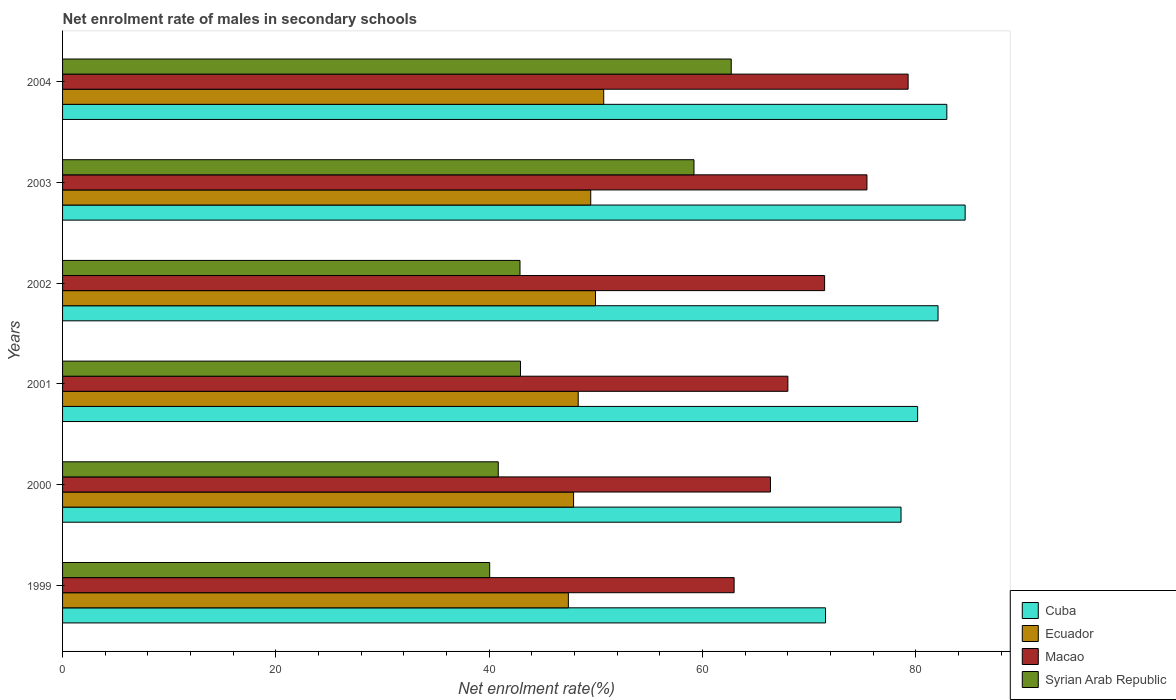How many bars are there on the 4th tick from the bottom?
Make the answer very short. 4. In how many cases, is the number of bars for a given year not equal to the number of legend labels?
Ensure brevity in your answer.  0. What is the net enrolment rate of males in secondary schools in Macao in 2002?
Provide a succinct answer. 71.46. Across all years, what is the maximum net enrolment rate of males in secondary schools in Macao?
Your response must be concise. 79.29. Across all years, what is the minimum net enrolment rate of males in secondary schools in Macao?
Your response must be concise. 62.97. In which year was the net enrolment rate of males in secondary schools in Cuba maximum?
Provide a succinct answer. 2003. What is the total net enrolment rate of males in secondary schools in Macao in the graph?
Provide a short and direct response. 423.53. What is the difference between the net enrolment rate of males in secondary schools in Syrian Arab Republic in 1999 and that in 2001?
Provide a succinct answer. -2.89. What is the difference between the net enrolment rate of males in secondary schools in Cuba in 2004 and the net enrolment rate of males in secondary schools in Macao in 2003?
Your answer should be compact. 7.49. What is the average net enrolment rate of males in secondary schools in Ecuador per year?
Make the answer very short. 48.99. In the year 2000, what is the difference between the net enrolment rate of males in secondary schools in Ecuador and net enrolment rate of males in secondary schools in Macao?
Give a very brief answer. -18.46. In how many years, is the net enrolment rate of males in secondary schools in Syrian Arab Republic greater than 12 %?
Provide a short and direct response. 6. What is the ratio of the net enrolment rate of males in secondary schools in Syrian Arab Republic in 1999 to that in 2003?
Offer a very short reply. 0.68. Is the net enrolment rate of males in secondary schools in Syrian Arab Republic in 1999 less than that in 2001?
Keep it short and to the point. Yes. Is the difference between the net enrolment rate of males in secondary schools in Ecuador in 2000 and 2002 greater than the difference between the net enrolment rate of males in secondary schools in Macao in 2000 and 2002?
Make the answer very short. Yes. What is the difference between the highest and the second highest net enrolment rate of males in secondary schools in Macao?
Your answer should be compact. 3.86. What is the difference between the highest and the lowest net enrolment rate of males in secondary schools in Cuba?
Give a very brief answer. 13.09. Is the sum of the net enrolment rate of males in secondary schools in Macao in 2002 and 2004 greater than the maximum net enrolment rate of males in secondary schools in Cuba across all years?
Make the answer very short. Yes. Is it the case that in every year, the sum of the net enrolment rate of males in secondary schools in Ecuador and net enrolment rate of males in secondary schools in Cuba is greater than the sum of net enrolment rate of males in secondary schools in Syrian Arab Republic and net enrolment rate of males in secondary schools in Macao?
Offer a very short reply. No. What does the 1st bar from the top in 2004 represents?
Your response must be concise. Syrian Arab Republic. What does the 3rd bar from the bottom in 2001 represents?
Offer a very short reply. Macao. How many bars are there?
Offer a very short reply. 24. What is the difference between two consecutive major ticks on the X-axis?
Keep it short and to the point. 20. Does the graph contain any zero values?
Make the answer very short. No. Where does the legend appear in the graph?
Ensure brevity in your answer.  Bottom right. What is the title of the graph?
Make the answer very short. Net enrolment rate of males in secondary schools. Does "Timor-Leste" appear as one of the legend labels in the graph?
Ensure brevity in your answer.  No. What is the label or title of the X-axis?
Your response must be concise. Net enrolment rate(%). What is the Net enrolment rate(%) in Cuba in 1999?
Your response must be concise. 71.54. What is the Net enrolment rate(%) in Ecuador in 1999?
Your response must be concise. 47.43. What is the Net enrolment rate(%) of Macao in 1999?
Offer a terse response. 62.97. What is the Net enrolment rate(%) of Syrian Arab Republic in 1999?
Provide a succinct answer. 40.05. What is the Net enrolment rate(%) of Cuba in 2000?
Provide a succinct answer. 78.62. What is the Net enrolment rate(%) in Ecuador in 2000?
Provide a short and direct response. 47.92. What is the Net enrolment rate(%) of Macao in 2000?
Provide a succinct answer. 66.38. What is the Net enrolment rate(%) of Syrian Arab Republic in 2000?
Your answer should be very brief. 40.86. What is the Net enrolment rate(%) of Cuba in 2001?
Provide a short and direct response. 80.18. What is the Net enrolment rate(%) in Ecuador in 2001?
Keep it short and to the point. 48.35. What is the Net enrolment rate(%) of Macao in 2001?
Make the answer very short. 68.01. What is the Net enrolment rate(%) in Syrian Arab Republic in 2001?
Keep it short and to the point. 42.94. What is the Net enrolment rate(%) of Cuba in 2002?
Ensure brevity in your answer.  82.09. What is the Net enrolment rate(%) of Ecuador in 2002?
Provide a succinct answer. 49.97. What is the Net enrolment rate(%) of Macao in 2002?
Give a very brief answer. 71.46. What is the Net enrolment rate(%) of Syrian Arab Republic in 2002?
Your answer should be very brief. 42.89. What is the Net enrolment rate(%) of Cuba in 2003?
Your response must be concise. 84.63. What is the Net enrolment rate(%) in Ecuador in 2003?
Make the answer very short. 49.53. What is the Net enrolment rate(%) of Macao in 2003?
Offer a very short reply. 75.43. What is the Net enrolment rate(%) of Syrian Arab Republic in 2003?
Your answer should be very brief. 59.21. What is the Net enrolment rate(%) in Cuba in 2004?
Give a very brief answer. 82.92. What is the Net enrolment rate(%) in Ecuador in 2004?
Your answer should be compact. 50.74. What is the Net enrolment rate(%) in Macao in 2004?
Make the answer very short. 79.29. What is the Net enrolment rate(%) in Syrian Arab Republic in 2004?
Offer a very short reply. 62.7. Across all years, what is the maximum Net enrolment rate(%) of Cuba?
Ensure brevity in your answer.  84.63. Across all years, what is the maximum Net enrolment rate(%) of Ecuador?
Give a very brief answer. 50.74. Across all years, what is the maximum Net enrolment rate(%) in Macao?
Provide a succinct answer. 79.29. Across all years, what is the maximum Net enrolment rate(%) of Syrian Arab Republic?
Provide a succinct answer. 62.7. Across all years, what is the minimum Net enrolment rate(%) in Cuba?
Offer a very short reply. 71.54. Across all years, what is the minimum Net enrolment rate(%) in Ecuador?
Make the answer very short. 47.43. Across all years, what is the minimum Net enrolment rate(%) in Macao?
Your answer should be compact. 62.97. Across all years, what is the minimum Net enrolment rate(%) of Syrian Arab Republic?
Provide a succinct answer. 40.05. What is the total Net enrolment rate(%) in Cuba in the graph?
Your answer should be very brief. 479.99. What is the total Net enrolment rate(%) of Ecuador in the graph?
Keep it short and to the point. 293.94. What is the total Net enrolment rate(%) in Macao in the graph?
Your answer should be compact. 423.53. What is the total Net enrolment rate(%) in Syrian Arab Republic in the graph?
Ensure brevity in your answer.  288.65. What is the difference between the Net enrolment rate(%) of Cuba in 1999 and that in 2000?
Keep it short and to the point. -7.08. What is the difference between the Net enrolment rate(%) in Ecuador in 1999 and that in 2000?
Keep it short and to the point. -0.49. What is the difference between the Net enrolment rate(%) of Macao in 1999 and that in 2000?
Your answer should be compact. -3.41. What is the difference between the Net enrolment rate(%) of Syrian Arab Republic in 1999 and that in 2000?
Offer a terse response. -0.8. What is the difference between the Net enrolment rate(%) in Cuba in 1999 and that in 2001?
Offer a terse response. -8.64. What is the difference between the Net enrolment rate(%) of Ecuador in 1999 and that in 2001?
Offer a terse response. -0.92. What is the difference between the Net enrolment rate(%) of Macao in 1999 and that in 2001?
Ensure brevity in your answer.  -5.04. What is the difference between the Net enrolment rate(%) in Syrian Arab Republic in 1999 and that in 2001?
Give a very brief answer. -2.89. What is the difference between the Net enrolment rate(%) in Cuba in 1999 and that in 2002?
Provide a short and direct response. -10.55. What is the difference between the Net enrolment rate(%) in Ecuador in 1999 and that in 2002?
Provide a short and direct response. -2.55. What is the difference between the Net enrolment rate(%) of Macao in 1999 and that in 2002?
Ensure brevity in your answer.  -8.49. What is the difference between the Net enrolment rate(%) of Syrian Arab Republic in 1999 and that in 2002?
Your answer should be very brief. -2.84. What is the difference between the Net enrolment rate(%) in Cuba in 1999 and that in 2003?
Make the answer very short. -13.09. What is the difference between the Net enrolment rate(%) in Ecuador in 1999 and that in 2003?
Offer a terse response. -2.1. What is the difference between the Net enrolment rate(%) of Macao in 1999 and that in 2003?
Your answer should be very brief. -12.46. What is the difference between the Net enrolment rate(%) of Syrian Arab Republic in 1999 and that in 2003?
Give a very brief answer. -19.16. What is the difference between the Net enrolment rate(%) in Cuba in 1999 and that in 2004?
Offer a terse response. -11.38. What is the difference between the Net enrolment rate(%) of Ecuador in 1999 and that in 2004?
Keep it short and to the point. -3.32. What is the difference between the Net enrolment rate(%) of Macao in 1999 and that in 2004?
Offer a very short reply. -16.32. What is the difference between the Net enrolment rate(%) of Syrian Arab Republic in 1999 and that in 2004?
Provide a short and direct response. -22.65. What is the difference between the Net enrolment rate(%) in Cuba in 2000 and that in 2001?
Your answer should be very brief. -1.56. What is the difference between the Net enrolment rate(%) of Ecuador in 2000 and that in 2001?
Your response must be concise. -0.43. What is the difference between the Net enrolment rate(%) in Macao in 2000 and that in 2001?
Your response must be concise. -1.63. What is the difference between the Net enrolment rate(%) in Syrian Arab Republic in 2000 and that in 2001?
Your answer should be very brief. -2.08. What is the difference between the Net enrolment rate(%) in Cuba in 2000 and that in 2002?
Keep it short and to the point. -3.47. What is the difference between the Net enrolment rate(%) of Ecuador in 2000 and that in 2002?
Your answer should be very brief. -2.06. What is the difference between the Net enrolment rate(%) of Macao in 2000 and that in 2002?
Your answer should be compact. -5.08. What is the difference between the Net enrolment rate(%) of Syrian Arab Republic in 2000 and that in 2002?
Offer a terse response. -2.04. What is the difference between the Net enrolment rate(%) of Cuba in 2000 and that in 2003?
Your response must be concise. -6.01. What is the difference between the Net enrolment rate(%) of Ecuador in 2000 and that in 2003?
Your response must be concise. -1.61. What is the difference between the Net enrolment rate(%) in Macao in 2000 and that in 2003?
Ensure brevity in your answer.  -9.05. What is the difference between the Net enrolment rate(%) of Syrian Arab Republic in 2000 and that in 2003?
Give a very brief answer. -18.35. What is the difference between the Net enrolment rate(%) of Cuba in 2000 and that in 2004?
Provide a short and direct response. -4.29. What is the difference between the Net enrolment rate(%) in Ecuador in 2000 and that in 2004?
Keep it short and to the point. -2.83. What is the difference between the Net enrolment rate(%) of Macao in 2000 and that in 2004?
Make the answer very short. -12.91. What is the difference between the Net enrolment rate(%) in Syrian Arab Republic in 2000 and that in 2004?
Your response must be concise. -21.85. What is the difference between the Net enrolment rate(%) of Cuba in 2001 and that in 2002?
Offer a terse response. -1.92. What is the difference between the Net enrolment rate(%) of Ecuador in 2001 and that in 2002?
Keep it short and to the point. -1.62. What is the difference between the Net enrolment rate(%) in Macao in 2001 and that in 2002?
Give a very brief answer. -3.45. What is the difference between the Net enrolment rate(%) in Syrian Arab Republic in 2001 and that in 2002?
Offer a terse response. 0.05. What is the difference between the Net enrolment rate(%) of Cuba in 2001 and that in 2003?
Provide a succinct answer. -4.46. What is the difference between the Net enrolment rate(%) in Ecuador in 2001 and that in 2003?
Give a very brief answer. -1.17. What is the difference between the Net enrolment rate(%) of Macao in 2001 and that in 2003?
Provide a short and direct response. -7.42. What is the difference between the Net enrolment rate(%) of Syrian Arab Republic in 2001 and that in 2003?
Offer a very short reply. -16.27. What is the difference between the Net enrolment rate(%) of Cuba in 2001 and that in 2004?
Ensure brevity in your answer.  -2.74. What is the difference between the Net enrolment rate(%) of Ecuador in 2001 and that in 2004?
Offer a very short reply. -2.39. What is the difference between the Net enrolment rate(%) in Macao in 2001 and that in 2004?
Give a very brief answer. -11.28. What is the difference between the Net enrolment rate(%) in Syrian Arab Republic in 2001 and that in 2004?
Ensure brevity in your answer.  -19.76. What is the difference between the Net enrolment rate(%) of Cuba in 2002 and that in 2003?
Give a very brief answer. -2.54. What is the difference between the Net enrolment rate(%) in Ecuador in 2002 and that in 2003?
Provide a short and direct response. 0.45. What is the difference between the Net enrolment rate(%) of Macao in 2002 and that in 2003?
Provide a short and direct response. -3.97. What is the difference between the Net enrolment rate(%) in Syrian Arab Republic in 2002 and that in 2003?
Your answer should be very brief. -16.31. What is the difference between the Net enrolment rate(%) in Cuba in 2002 and that in 2004?
Your answer should be very brief. -0.82. What is the difference between the Net enrolment rate(%) of Ecuador in 2002 and that in 2004?
Ensure brevity in your answer.  -0.77. What is the difference between the Net enrolment rate(%) in Macao in 2002 and that in 2004?
Give a very brief answer. -7.83. What is the difference between the Net enrolment rate(%) of Syrian Arab Republic in 2002 and that in 2004?
Keep it short and to the point. -19.81. What is the difference between the Net enrolment rate(%) of Cuba in 2003 and that in 2004?
Offer a very short reply. 1.72. What is the difference between the Net enrolment rate(%) of Ecuador in 2003 and that in 2004?
Provide a short and direct response. -1.22. What is the difference between the Net enrolment rate(%) in Macao in 2003 and that in 2004?
Provide a succinct answer. -3.86. What is the difference between the Net enrolment rate(%) of Syrian Arab Republic in 2003 and that in 2004?
Give a very brief answer. -3.49. What is the difference between the Net enrolment rate(%) of Cuba in 1999 and the Net enrolment rate(%) of Ecuador in 2000?
Ensure brevity in your answer.  23.62. What is the difference between the Net enrolment rate(%) of Cuba in 1999 and the Net enrolment rate(%) of Macao in 2000?
Provide a succinct answer. 5.16. What is the difference between the Net enrolment rate(%) in Cuba in 1999 and the Net enrolment rate(%) in Syrian Arab Republic in 2000?
Your answer should be very brief. 30.69. What is the difference between the Net enrolment rate(%) of Ecuador in 1999 and the Net enrolment rate(%) of Macao in 2000?
Make the answer very short. -18.95. What is the difference between the Net enrolment rate(%) in Ecuador in 1999 and the Net enrolment rate(%) in Syrian Arab Republic in 2000?
Make the answer very short. 6.57. What is the difference between the Net enrolment rate(%) of Macao in 1999 and the Net enrolment rate(%) of Syrian Arab Republic in 2000?
Provide a short and direct response. 22.12. What is the difference between the Net enrolment rate(%) of Cuba in 1999 and the Net enrolment rate(%) of Ecuador in 2001?
Give a very brief answer. 23.19. What is the difference between the Net enrolment rate(%) in Cuba in 1999 and the Net enrolment rate(%) in Macao in 2001?
Give a very brief answer. 3.53. What is the difference between the Net enrolment rate(%) in Cuba in 1999 and the Net enrolment rate(%) in Syrian Arab Republic in 2001?
Offer a very short reply. 28.6. What is the difference between the Net enrolment rate(%) of Ecuador in 1999 and the Net enrolment rate(%) of Macao in 2001?
Ensure brevity in your answer.  -20.58. What is the difference between the Net enrolment rate(%) in Ecuador in 1999 and the Net enrolment rate(%) in Syrian Arab Republic in 2001?
Your answer should be compact. 4.49. What is the difference between the Net enrolment rate(%) of Macao in 1999 and the Net enrolment rate(%) of Syrian Arab Republic in 2001?
Offer a terse response. 20.03. What is the difference between the Net enrolment rate(%) of Cuba in 1999 and the Net enrolment rate(%) of Ecuador in 2002?
Offer a very short reply. 21.57. What is the difference between the Net enrolment rate(%) in Cuba in 1999 and the Net enrolment rate(%) in Macao in 2002?
Make the answer very short. 0.09. What is the difference between the Net enrolment rate(%) in Cuba in 1999 and the Net enrolment rate(%) in Syrian Arab Republic in 2002?
Ensure brevity in your answer.  28.65. What is the difference between the Net enrolment rate(%) of Ecuador in 1999 and the Net enrolment rate(%) of Macao in 2002?
Your response must be concise. -24.03. What is the difference between the Net enrolment rate(%) in Ecuador in 1999 and the Net enrolment rate(%) in Syrian Arab Republic in 2002?
Offer a very short reply. 4.53. What is the difference between the Net enrolment rate(%) of Macao in 1999 and the Net enrolment rate(%) of Syrian Arab Republic in 2002?
Your answer should be very brief. 20.08. What is the difference between the Net enrolment rate(%) in Cuba in 1999 and the Net enrolment rate(%) in Ecuador in 2003?
Give a very brief answer. 22.02. What is the difference between the Net enrolment rate(%) of Cuba in 1999 and the Net enrolment rate(%) of Macao in 2003?
Your answer should be compact. -3.88. What is the difference between the Net enrolment rate(%) in Cuba in 1999 and the Net enrolment rate(%) in Syrian Arab Republic in 2003?
Ensure brevity in your answer.  12.33. What is the difference between the Net enrolment rate(%) in Ecuador in 1999 and the Net enrolment rate(%) in Macao in 2003?
Provide a short and direct response. -28. What is the difference between the Net enrolment rate(%) in Ecuador in 1999 and the Net enrolment rate(%) in Syrian Arab Republic in 2003?
Ensure brevity in your answer.  -11.78. What is the difference between the Net enrolment rate(%) of Macao in 1999 and the Net enrolment rate(%) of Syrian Arab Republic in 2003?
Ensure brevity in your answer.  3.76. What is the difference between the Net enrolment rate(%) of Cuba in 1999 and the Net enrolment rate(%) of Ecuador in 2004?
Your answer should be compact. 20.8. What is the difference between the Net enrolment rate(%) of Cuba in 1999 and the Net enrolment rate(%) of Macao in 2004?
Keep it short and to the point. -7.75. What is the difference between the Net enrolment rate(%) in Cuba in 1999 and the Net enrolment rate(%) in Syrian Arab Republic in 2004?
Your answer should be compact. 8.84. What is the difference between the Net enrolment rate(%) of Ecuador in 1999 and the Net enrolment rate(%) of Macao in 2004?
Offer a very short reply. -31.86. What is the difference between the Net enrolment rate(%) of Ecuador in 1999 and the Net enrolment rate(%) of Syrian Arab Republic in 2004?
Provide a short and direct response. -15.27. What is the difference between the Net enrolment rate(%) in Macao in 1999 and the Net enrolment rate(%) in Syrian Arab Republic in 2004?
Provide a short and direct response. 0.27. What is the difference between the Net enrolment rate(%) in Cuba in 2000 and the Net enrolment rate(%) in Ecuador in 2001?
Give a very brief answer. 30.27. What is the difference between the Net enrolment rate(%) of Cuba in 2000 and the Net enrolment rate(%) of Macao in 2001?
Provide a short and direct response. 10.61. What is the difference between the Net enrolment rate(%) in Cuba in 2000 and the Net enrolment rate(%) in Syrian Arab Republic in 2001?
Make the answer very short. 35.68. What is the difference between the Net enrolment rate(%) in Ecuador in 2000 and the Net enrolment rate(%) in Macao in 2001?
Your response must be concise. -20.09. What is the difference between the Net enrolment rate(%) in Ecuador in 2000 and the Net enrolment rate(%) in Syrian Arab Republic in 2001?
Keep it short and to the point. 4.98. What is the difference between the Net enrolment rate(%) in Macao in 2000 and the Net enrolment rate(%) in Syrian Arab Republic in 2001?
Provide a succinct answer. 23.44. What is the difference between the Net enrolment rate(%) in Cuba in 2000 and the Net enrolment rate(%) in Ecuador in 2002?
Your response must be concise. 28.65. What is the difference between the Net enrolment rate(%) in Cuba in 2000 and the Net enrolment rate(%) in Macao in 2002?
Offer a very short reply. 7.17. What is the difference between the Net enrolment rate(%) in Cuba in 2000 and the Net enrolment rate(%) in Syrian Arab Republic in 2002?
Provide a short and direct response. 35.73. What is the difference between the Net enrolment rate(%) of Ecuador in 2000 and the Net enrolment rate(%) of Macao in 2002?
Provide a short and direct response. -23.54. What is the difference between the Net enrolment rate(%) in Ecuador in 2000 and the Net enrolment rate(%) in Syrian Arab Republic in 2002?
Offer a terse response. 5.02. What is the difference between the Net enrolment rate(%) in Macao in 2000 and the Net enrolment rate(%) in Syrian Arab Republic in 2002?
Offer a terse response. 23.49. What is the difference between the Net enrolment rate(%) of Cuba in 2000 and the Net enrolment rate(%) of Ecuador in 2003?
Your answer should be compact. 29.1. What is the difference between the Net enrolment rate(%) of Cuba in 2000 and the Net enrolment rate(%) of Macao in 2003?
Your answer should be very brief. 3.2. What is the difference between the Net enrolment rate(%) in Cuba in 2000 and the Net enrolment rate(%) in Syrian Arab Republic in 2003?
Provide a short and direct response. 19.42. What is the difference between the Net enrolment rate(%) in Ecuador in 2000 and the Net enrolment rate(%) in Macao in 2003?
Provide a short and direct response. -27.51. What is the difference between the Net enrolment rate(%) in Ecuador in 2000 and the Net enrolment rate(%) in Syrian Arab Republic in 2003?
Your answer should be very brief. -11.29. What is the difference between the Net enrolment rate(%) of Macao in 2000 and the Net enrolment rate(%) of Syrian Arab Republic in 2003?
Give a very brief answer. 7.17. What is the difference between the Net enrolment rate(%) of Cuba in 2000 and the Net enrolment rate(%) of Ecuador in 2004?
Give a very brief answer. 27.88. What is the difference between the Net enrolment rate(%) in Cuba in 2000 and the Net enrolment rate(%) in Macao in 2004?
Give a very brief answer. -0.66. What is the difference between the Net enrolment rate(%) of Cuba in 2000 and the Net enrolment rate(%) of Syrian Arab Republic in 2004?
Your answer should be compact. 15.92. What is the difference between the Net enrolment rate(%) of Ecuador in 2000 and the Net enrolment rate(%) of Macao in 2004?
Give a very brief answer. -31.37. What is the difference between the Net enrolment rate(%) of Ecuador in 2000 and the Net enrolment rate(%) of Syrian Arab Republic in 2004?
Provide a short and direct response. -14.78. What is the difference between the Net enrolment rate(%) in Macao in 2000 and the Net enrolment rate(%) in Syrian Arab Republic in 2004?
Keep it short and to the point. 3.68. What is the difference between the Net enrolment rate(%) in Cuba in 2001 and the Net enrolment rate(%) in Ecuador in 2002?
Your answer should be very brief. 30.21. What is the difference between the Net enrolment rate(%) of Cuba in 2001 and the Net enrolment rate(%) of Macao in 2002?
Keep it short and to the point. 8.72. What is the difference between the Net enrolment rate(%) in Cuba in 2001 and the Net enrolment rate(%) in Syrian Arab Republic in 2002?
Provide a short and direct response. 37.28. What is the difference between the Net enrolment rate(%) of Ecuador in 2001 and the Net enrolment rate(%) of Macao in 2002?
Offer a very short reply. -23.11. What is the difference between the Net enrolment rate(%) in Ecuador in 2001 and the Net enrolment rate(%) in Syrian Arab Republic in 2002?
Your answer should be very brief. 5.46. What is the difference between the Net enrolment rate(%) in Macao in 2001 and the Net enrolment rate(%) in Syrian Arab Republic in 2002?
Keep it short and to the point. 25.12. What is the difference between the Net enrolment rate(%) of Cuba in 2001 and the Net enrolment rate(%) of Ecuador in 2003?
Your response must be concise. 30.65. What is the difference between the Net enrolment rate(%) in Cuba in 2001 and the Net enrolment rate(%) in Macao in 2003?
Your answer should be very brief. 4.75. What is the difference between the Net enrolment rate(%) in Cuba in 2001 and the Net enrolment rate(%) in Syrian Arab Republic in 2003?
Offer a very short reply. 20.97. What is the difference between the Net enrolment rate(%) of Ecuador in 2001 and the Net enrolment rate(%) of Macao in 2003?
Your response must be concise. -27.07. What is the difference between the Net enrolment rate(%) in Ecuador in 2001 and the Net enrolment rate(%) in Syrian Arab Republic in 2003?
Your response must be concise. -10.86. What is the difference between the Net enrolment rate(%) in Macao in 2001 and the Net enrolment rate(%) in Syrian Arab Republic in 2003?
Your answer should be compact. 8.8. What is the difference between the Net enrolment rate(%) in Cuba in 2001 and the Net enrolment rate(%) in Ecuador in 2004?
Offer a terse response. 29.44. What is the difference between the Net enrolment rate(%) in Cuba in 2001 and the Net enrolment rate(%) in Macao in 2004?
Offer a terse response. 0.89. What is the difference between the Net enrolment rate(%) of Cuba in 2001 and the Net enrolment rate(%) of Syrian Arab Republic in 2004?
Offer a very short reply. 17.48. What is the difference between the Net enrolment rate(%) in Ecuador in 2001 and the Net enrolment rate(%) in Macao in 2004?
Offer a terse response. -30.94. What is the difference between the Net enrolment rate(%) in Ecuador in 2001 and the Net enrolment rate(%) in Syrian Arab Republic in 2004?
Your answer should be very brief. -14.35. What is the difference between the Net enrolment rate(%) of Macao in 2001 and the Net enrolment rate(%) of Syrian Arab Republic in 2004?
Make the answer very short. 5.31. What is the difference between the Net enrolment rate(%) in Cuba in 2002 and the Net enrolment rate(%) in Ecuador in 2003?
Your answer should be compact. 32.57. What is the difference between the Net enrolment rate(%) of Cuba in 2002 and the Net enrolment rate(%) of Macao in 2003?
Your answer should be compact. 6.67. What is the difference between the Net enrolment rate(%) in Cuba in 2002 and the Net enrolment rate(%) in Syrian Arab Republic in 2003?
Your answer should be compact. 22.89. What is the difference between the Net enrolment rate(%) of Ecuador in 2002 and the Net enrolment rate(%) of Macao in 2003?
Make the answer very short. -25.45. What is the difference between the Net enrolment rate(%) of Ecuador in 2002 and the Net enrolment rate(%) of Syrian Arab Republic in 2003?
Offer a very short reply. -9.23. What is the difference between the Net enrolment rate(%) of Macao in 2002 and the Net enrolment rate(%) of Syrian Arab Republic in 2003?
Your answer should be very brief. 12.25. What is the difference between the Net enrolment rate(%) in Cuba in 2002 and the Net enrolment rate(%) in Ecuador in 2004?
Provide a short and direct response. 31.35. What is the difference between the Net enrolment rate(%) of Cuba in 2002 and the Net enrolment rate(%) of Macao in 2004?
Offer a terse response. 2.81. What is the difference between the Net enrolment rate(%) of Cuba in 2002 and the Net enrolment rate(%) of Syrian Arab Republic in 2004?
Your answer should be compact. 19.39. What is the difference between the Net enrolment rate(%) of Ecuador in 2002 and the Net enrolment rate(%) of Macao in 2004?
Offer a very short reply. -29.32. What is the difference between the Net enrolment rate(%) of Ecuador in 2002 and the Net enrolment rate(%) of Syrian Arab Republic in 2004?
Give a very brief answer. -12.73. What is the difference between the Net enrolment rate(%) of Macao in 2002 and the Net enrolment rate(%) of Syrian Arab Republic in 2004?
Provide a short and direct response. 8.76. What is the difference between the Net enrolment rate(%) in Cuba in 2003 and the Net enrolment rate(%) in Ecuador in 2004?
Keep it short and to the point. 33.89. What is the difference between the Net enrolment rate(%) of Cuba in 2003 and the Net enrolment rate(%) of Macao in 2004?
Give a very brief answer. 5.35. What is the difference between the Net enrolment rate(%) in Cuba in 2003 and the Net enrolment rate(%) in Syrian Arab Republic in 2004?
Offer a very short reply. 21.93. What is the difference between the Net enrolment rate(%) in Ecuador in 2003 and the Net enrolment rate(%) in Macao in 2004?
Make the answer very short. -29.76. What is the difference between the Net enrolment rate(%) in Ecuador in 2003 and the Net enrolment rate(%) in Syrian Arab Republic in 2004?
Your answer should be compact. -13.17. What is the difference between the Net enrolment rate(%) in Macao in 2003 and the Net enrolment rate(%) in Syrian Arab Republic in 2004?
Ensure brevity in your answer.  12.73. What is the average Net enrolment rate(%) of Cuba per year?
Provide a succinct answer. 80. What is the average Net enrolment rate(%) in Ecuador per year?
Give a very brief answer. 48.99. What is the average Net enrolment rate(%) in Macao per year?
Give a very brief answer. 70.59. What is the average Net enrolment rate(%) in Syrian Arab Republic per year?
Your answer should be compact. 48.11. In the year 1999, what is the difference between the Net enrolment rate(%) of Cuba and Net enrolment rate(%) of Ecuador?
Your answer should be very brief. 24.11. In the year 1999, what is the difference between the Net enrolment rate(%) of Cuba and Net enrolment rate(%) of Macao?
Ensure brevity in your answer.  8.57. In the year 1999, what is the difference between the Net enrolment rate(%) in Cuba and Net enrolment rate(%) in Syrian Arab Republic?
Ensure brevity in your answer.  31.49. In the year 1999, what is the difference between the Net enrolment rate(%) of Ecuador and Net enrolment rate(%) of Macao?
Make the answer very short. -15.54. In the year 1999, what is the difference between the Net enrolment rate(%) in Ecuador and Net enrolment rate(%) in Syrian Arab Republic?
Give a very brief answer. 7.38. In the year 1999, what is the difference between the Net enrolment rate(%) of Macao and Net enrolment rate(%) of Syrian Arab Republic?
Keep it short and to the point. 22.92. In the year 2000, what is the difference between the Net enrolment rate(%) of Cuba and Net enrolment rate(%) of Ecuador?
Offer a terse response. 30.71. In the year 2000, what is the difference between the Net enrolment rate(%) of Cuba and Net enrolment rate(%) of Macao?
Provide a short and direct response. 12.24. In the year 2000, what is the difference between the Net enrolment rate(%) in Cuba and Net enrolment rate(%) in Syrian Arab Republic?
Your answer should be compact. 37.77. In the year 2000, what is the difference between the Net enrolment rate(%) of Ecuador and Net enrolment rate(%) of Macao?
Ensure brevity in your answer.  -18.46. In the year 2000, what is the difference between the Net enrolment rate(%) in Ecuador and Net enrolment rate(%) in Syrian Arab Republic?
Your answer should be compact. 7.06. In the year 2000, what is the difference between the Net enrolment rate(%) in Macao and Net enrolment rate(%) in Syrian Arab Republic?
Your answer should be very brief. 25.52. In the year 2001, what is the difference between the Net enrolment rate(%) of Cuba and Net enrolment rate(%) of Ecuador?
Make the answer very short. 31.83. In the year 2001, what is the difference between the Net enrolment rate(%) of Cuba and Net enrolment rate(%) of Macao?
Your answer should be compact. 12.17. In the year 2001, what is the difference between the Net enrolment rate(%) of Cuba and Net enrolment rate(%) of Syrian Arab Republic?
Provide a succinct answer. 37.24. In the year 2001, what is the difference between the Net enrolment rate(%) in Ecuador and Net enrolment rate(%) in Macao?
Provide a succinct answer. -19.66. In the year 2001, what is the difference between the Net enrolment rate(%) in Ecuador and Net enrolment rate(%) in Syrian Arab Republic?
Ensure brevity in your answer.  5.41. In the year 2001, what is the difference between the Net enrolment rate(%) of Macao and Net enrolment rate(%) of Syrian Arab Republic?
Provide a short and direct response. 25.07. In the year 2002, what is the difference between the Net enrolment rate(%) in Cuba and Net enrolment rate(%) in Ecuador?
Ensure brevity in your answer.  32.12. In the year 2002, what is the difference between the Net enrolment rate(%) in Cuba and Net enrolment rate(%) in Macao?
Provide a succinct answer. 10.64. In the year 2002, what is the difference between the Net enrolment rate(%) of Cuba and Net enrolment rate(%) of Syrian Arab Republic?
Provide a short and direct response. 39.2. In the year 2002, what is the difference between the Net enrolment rate(%) of Ecuador and Net enrolment rate(%) of Macao?
Provide a succinct answer. -21.48. In the year 2002, what is the difference between the Net enrolment rate(%) in Ecuador and Net enrolment rate(%) in Syrian Arab Republic?
Give a very brief answer. 7.08. In the year 2002, what is the difference between the Net enrolment rate(%) of Macao and Net enrolment rate(%) of Syrian Arab Republic?
Give a very brief answer. 28.56. In the year 2003, what is the difference between the Net enrolment rate(%) of Cuba and Net enrolment rate(%) of Ecuador?
Ensure brevity in your answer.  35.11. In the year 2003, what is the difference between the Net enrolment rate(%) in Cuba and Net enrolment rate(%) in Macao?
Provide a short and direct response. 9.21. In the year 2003, what is the difference between the Net enrolment rate(%) of Cuba and Net enrolment rate(%) of Syrian Arab Republic?
Give a very brief answer. 25.43. In the year 2003, what is the difference between the Net enrolment rate(%) in Ecuador and Net enrolment rate(%) in Macao?
Keep it short and to the point. -25.9. In the year 2003, what is the difference between the Net enrolment rate(%) in Ecuador and Net enrolment rate(%) in Syrian Arab Republic?
Your answer should be compact. -9.68. In the year 2003, what is the difference between the Net enrolment rate(%) of Macao and Net enrolment rate(%) of Syrian Arab Republic?
Your answer should be very brief. 16.22. In the year 2004, what is the difference between the Net enrolment rate(%) in Cuba and Net enrolment rate(%) in Ecuador?
Your answer should be compact. 32.17. In the year 2004, what is the difference between the Net enrolment rate(%) of Cuba and Net enrolment rate(%) of Macao?
Offer a terse response. 3.63. In the year 2004, what is the difference between the Net enrolment rate(%) of Cuba and Net enrolment rate(%) of Syrian Arab Republic?
Provide a short and direct response. 20.22. In the year 2004, what is the difference between the Net enrolment rate(%) of Ecuador and Net enrolment rate(%) of Macao?
Your answer should be very brief. -28.55. In the year 2004, what is the difference between the Net enrolment rate(%) in Ecuador and Net enrolment rate(%) in Syrian Arab Republic?
Your answer should be very brief. -11.96. In the year 2004, what is the difference between the Net enrolment rate(%) of Macao and Net enrolment rate(%) of Syrian Arab Republic?
Your response must be concise. 16.59. What is the ratio of the Net enrolment rate(%) in Cuba in 1999 to that in 2000?
Offer a very short reply. 0.91. What is the ratio of the Net enrolment rate(%) of Macao in 1999 to that in 2000?
Provide a short and direct response. 0.95. What is the ratio of the Net enrolment rate(%) of Syrian Arab Republic in 1999 to that in 2000?
Provide a succinct answer. 0.98. What is the ratio of the Net enrolment rate(%) of Cuba in 1999 to that in 2001?
Make the answer very short. 0.89. What is the ratio of the Net enrolment rate(%) in Ecuador in 1999 to that in 2001?
Keep it short and to the point. 0.98. What is the ratio of the Net enrolment rate(%) of Macao in 1999 to that in 2001?
Offer a terse response. 0.93. What is the ratio of the Net enrolment rate(%) of Syrian Arab Republic in 1999 to that in 2001?
Give a very brief answer. 0.93. What is the ratio of the Net enrolment rate(%) of Cuba in 1999 to that in 2002?
Give a very brief answer. 0.87. What is the ratio of the Net enrolment rate(%) in Ecuador in 1999 to that in 2002?
Provide a short and direct response. 0.95. What is the ratio of the Net enrolment rate(%) in Macao in 1999 to that in 2002?
Keep it short and to the point. 0.88. What is the ratio of the Net enrolment rate(%) in Syrian Arab Republic in 1999 to that in 2002?
Keep it short and to the point. 0.93. What is the ratio of the Net enrolment rate(%) in Cuba in 1999 to that in 2003?
Provide a short and direct response. 0.85. What is the ratio of the Net enrolment rate(%) of Ecuador in 1999 to that in 2003?
Keep it short and to the point. 0.96. What is the ratio of the Net enrolment rate(%) of Macao in 1999 to that in 2003?
Offer a terse response. 0.83. What is the ratio of the Net enrolment rate(%) of Syrian Arab Republic in 1999 to that in 2003?
Keep it short and to the point. 0.68. What is the ratio of the Net enrolment rate(%) of Cuba in 1999 to that in 2004?
Offer a very short reply. 0.86. What is the ratio of the Net enrolment rate(%) in Ecuador in 1999 to that in 2004?
Keep it short and to the point. 0.93. What is the ratio of the Net enrolment rate(%) of Macao in 1999 to that in 2004?
Provide a succinct answer. 0.79. What is the ratio of the Net enrolment rate(%) in Syrian Arab Republic in 1999 to that in 2004?
Provide a short and direct response. 0.64. What is the ratio of the Net enrolment rate(%) of Cuba in 2000 to that in 2001?
Ensure brevity in your answer.  0.98. What is the ratio of the Net enrolment rate(%) in Ecuador in 2000 to that in 2001?
Make the answer very short. 0.99. What is the ratio of the Net enrolment rate(%) of Macao in 2000 to that in 2001?
Your response must be concise. 0.98. What is the ratio of the Net enrolment rate(%) of Syrian Arab Republic in 2000 to that in 2001?
Your answer should be compact. 0.95. What is the ratio of the Net enrolment rate(%) in Cuba in 2000 to that in 2002?
Provide a short and direct response. 0.96. What is the ratio of the Net enrolment rate(%) of Ecuador in 2000 to that in 2002?
Your answer should be very brief. 0.96. What is the ratio of the Net enrolment rate(%) of Macao in 2000 to that in 2002?
Your answer should be compact. 0.93. What is the ratio of the Net enrolment rate(%) of Syrian Arab Republic in 2000 to that in 2002?
Provide a succinct answer. 0.95. What is the ratio of the Net enrolment rate(%) in Cuba in 2000 to that in 2003?
Give a very brief answer. 0.93. What is the ratio of the Net enrolment rate(%) of Ecuador in 2000 to that in 2003?
Provide a succinct answer. 0.97. What is the ratio of the Net enrolment rate(%) of Syrian Arab Republic in 2000 to that in 2003?
Provide a short and direct response. 0.69. What is the ratio of the Net enrolment rate(%) of Cuba in 2000 to that in 2004?
Your response must be concise. 0.95. What is the ratio of the Net enrolment rate(%) in Ecuador in 2000 to that in 2004?
Your response must be concise. 0.94. What is the ratio of the Net enrolment rate(%) in Macao in 2000 to that in 2004?
Give a very brief answer. 0.84. What is the ratio of the Net enrolment rate(%) of Syrian Arab Republic in 2000 to that in 2004?
Give a very brief answer. 0.65. What is the ratio of the Net enrolment rate(%) in Cuba in 2001 to that in 2002?
Your answer should be very brief. 0.98. What is the ratio of the Net enrolment rate(%) of Ecuador in 2001 to that in 2002?
Offer a terse response. 0.97. What is the ratio of the Net enrolment rate(%) of Macao in 2001 to that in 2002?
Your response must be concise. 0.95. What is the ratio of the Net enrolment rate(%) in Cuba in 2001 to that in 2003?
Your answer should be very brief. 0.95. What is the ratio of the Net enrolment rate(%) of Ecuador in 2001 to that in 2003?
Ensure brevity in your answer.  0.98. What is the ratio of the Net enrolment rate(%) of Macao in 2001 to that in 2003?
Give a very brief answer. 0.9. What is the ratio of the Net enrolment rate(%) of Syrian Arab Republic in 2001 to that in 2003?
Your answer should be compact. 0.73. What is the ratio of the Net enrolment rate(%) of Ecuador in 2001 to that in 2004?
Ensure brevity in your answer.  0.95. What is the ratio of the Net enrolment rate(%) in Macao in 2001 to that in 2004?
Your answer should be compact. 0.86. What is the ratio of the Net enrolment rate(%) in Syrian Arab Republic in 2001 to that in 2004?
Provide a short and direct response. 0.68. What is the ratio of the Net enrolment rate(%) of Cuba in 2002 to that in 2003?
Your response must be concise. 0.97. What is the ratio of the Net enrolment rate(%) in Syrian Arab Republic in 2002 to that in 2003?
Provide a succinct answer. 0.72. What is the ratio of the Net enrolment rate(%) of Cuba in 2002 to that in 2004?
Give a very brief answer. 0.99. What is the ratio of the Net enrolment rate(%) of Ecuador in 2002 to that in 2004?
Provide a short and direct response. 0.98. What is the ratio of the Net enrolment rate(%) in Macao in 2002 to that in 2004?
Ensure brevity in your answer.  0.9. What is the ratio of the Net enrolment rate(%) in Syrian Arab Republic in 2002 to that in 2004?
Ensure brevity in your answer.  0.68. What is the ratio of the Net enrolment rate(%) in Cuba in 2003 to that in 2004?
Make the answer very short. 1.02. What is the ratio of the Net enrolment rate(%) in Macao in 2003 to that in 2004?
Keep it short and to the point. 0.95. What is the ratio of the Net enrolment rate(%) in Syrian Arab Republic in 2003 to that in 2004?
Offer a terse response. 0.94. What is the difference between the highest and the second highest Net enrolment rate(%) of Cuba?
Offer a very short reply. 1.72. What is the difference between the highest and the second highest Net enrolment rate(%) of Ecuador?
Keep it short and to the point. 0.77. What is the difference between the highest and the second highest Net enrolment rate(%) of Macao?
Your answer should be very brief. 3.86. What is the difference between the highest and the second highest Net enrolment rate(%) in Syrian Arab Republic?
Offer a terse response. 3.49. What is the difference between the highest and the lowest Net enrolment rate(%) of Cuba?
Offer a terse response. 13.09. What is the difference between the highest and the lowest Net enrolment rate(%) in Ecuador?
Keep it short and to the point. 3.32. What is the difference between the highest and the lowest Net enrolment rate(%) in Macao?
Give a very brief answer. 16.32. What is the difference between the highest and the lowest Net enrolment rate(%) in Syrian Arab Republic?
Provide a short and direct response. 22.65. 